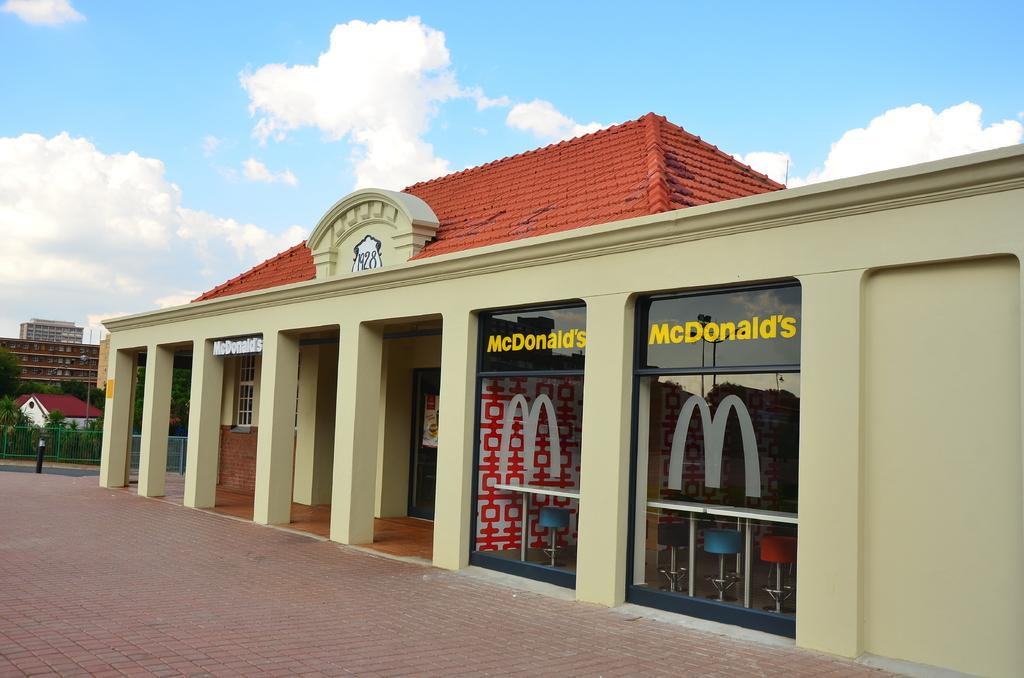<image>
Provide a brief description of the given image. A McDonald's has a numeric street address of 1928. 